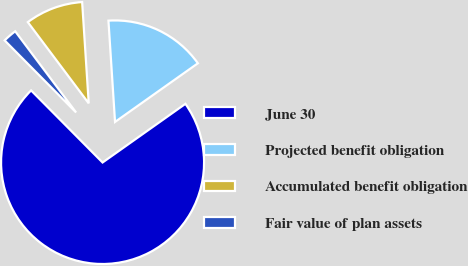Convert chart. <chart><loc_0><loc_0><loc_500><loc_500><pie_chart><fcel>June 30<fcel>Projected benefit obligation<fcel>Accumulated benefit obligation<fcel>Fair value of plan assets<nl><fcel>72.38%<fcel>16.23%<fcel>9.21%<fcel>2.19%<nl></chart> 